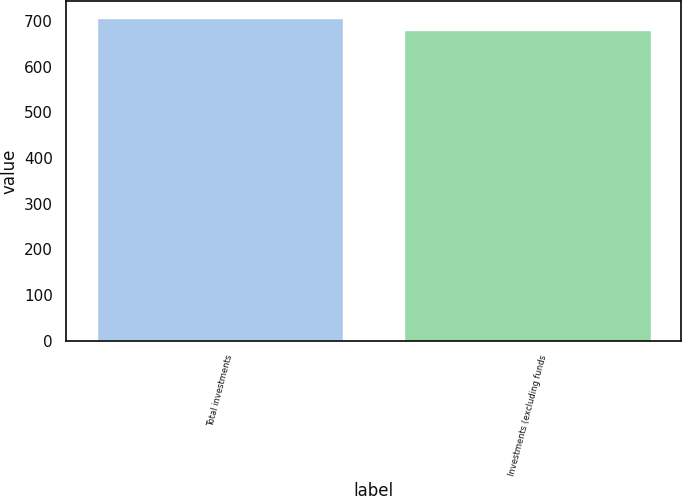Convert chart. <chart><loc_0><loc_0><loc_500><loc_500><bar_chart><fcel>Total investments<fcel>Investments (excluding funds<nl><fcel>708<fcel>680<nl></chart> 